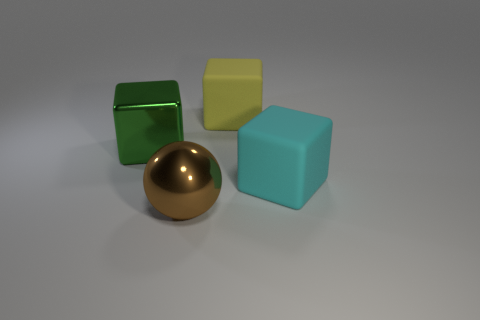What number of matte things are either purple cubes or cyan cubes?
Keep it short and to the point. 1. The large yellow thing is what shape?
Give a very brief answer. Cube. How many big green blocks have the same material as the large cyan object?
Keep it short and to the point. 0. The big sphere that is the same material as the big green thing is what color?
Keep it short and to the point. Brown. Is the size of the brown metal thing that is to the left of the cyan cube the same as the large cyan matte thing?
Your response must be concise. Yes. What color is the other matte object that is the same shape as the large cyan thing?
Your answer should be very brief. Yellow. There is a big cyan matte thing on the right side of the big metal object behind the large rubber block in front of the shiny cube; what shape is it?
Your response must be concise. Cube. Is the shape of the large green thing the same as the cyan matte object?
Offer a terse response. Yes. There is a big rubber thing behind the metal object on the left side of the large brown sphere; what shape is it?
Your answer should be very brief. Cube. Is there a big green object?
Offer a very short reply. Yes. 